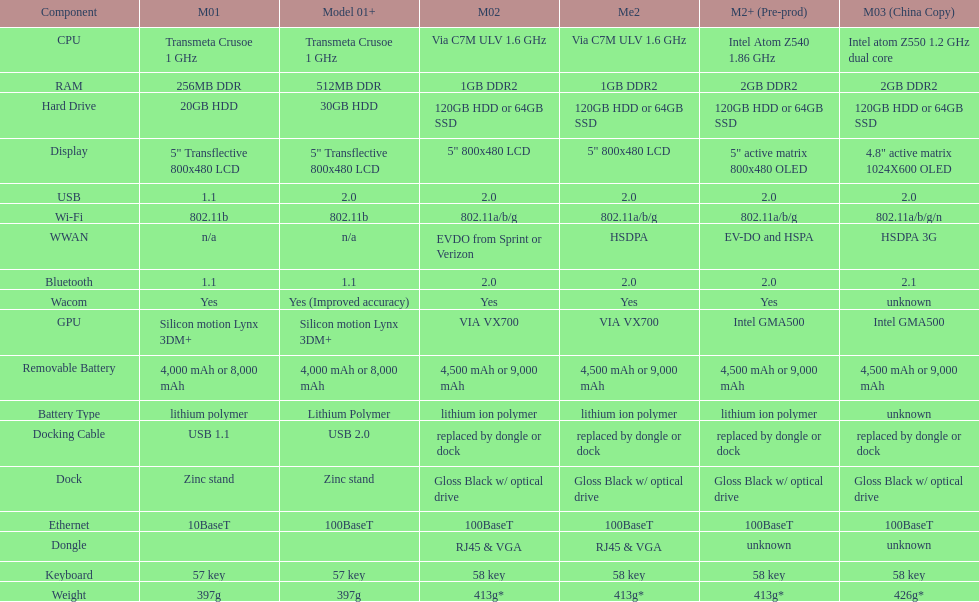How much more weight does the model 3 have over model 1? 29g. 